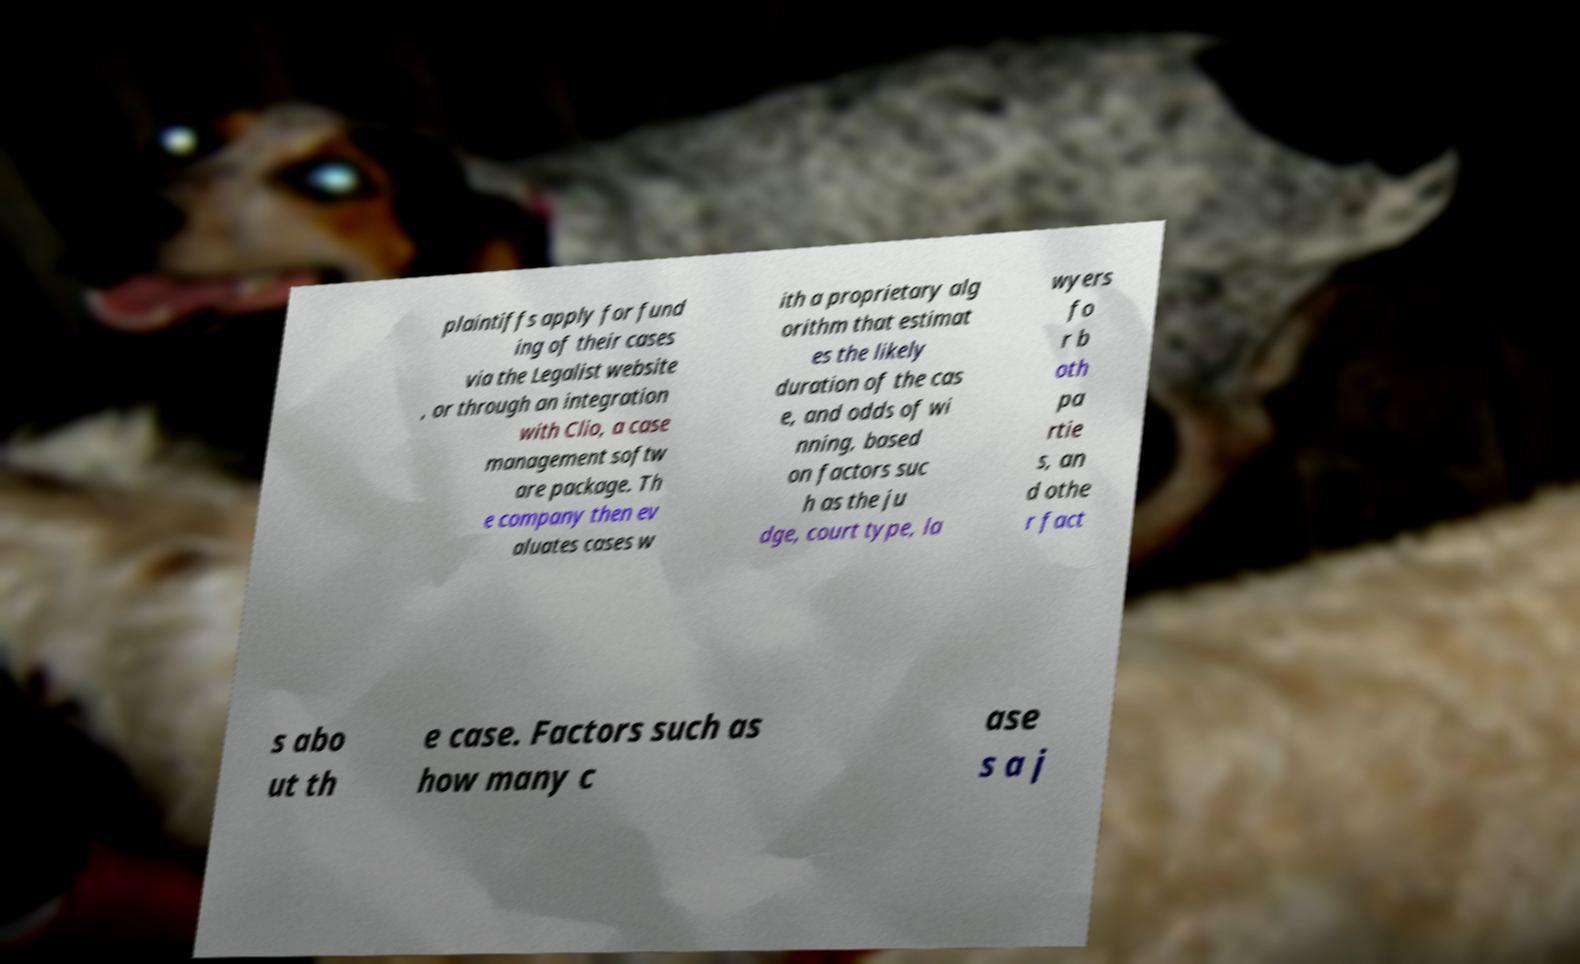For documentation purposes, I need the text within this image transcribed. Could you provide that? plaintiffs apply for fund ing of their cases via the Legalist website , or through an integration with Clio, a case management softw are package. Th e company then ev aluates cases w ith a proprietary alg orithm that estimat es the likely duration of the cas e, and odds of wi nning, based on factors suc h as the ju dge, court type, la wyers fo r b oth pa rtie s, an d othe r fact s abo ut th e case. Factors such as how many c ase s a j 